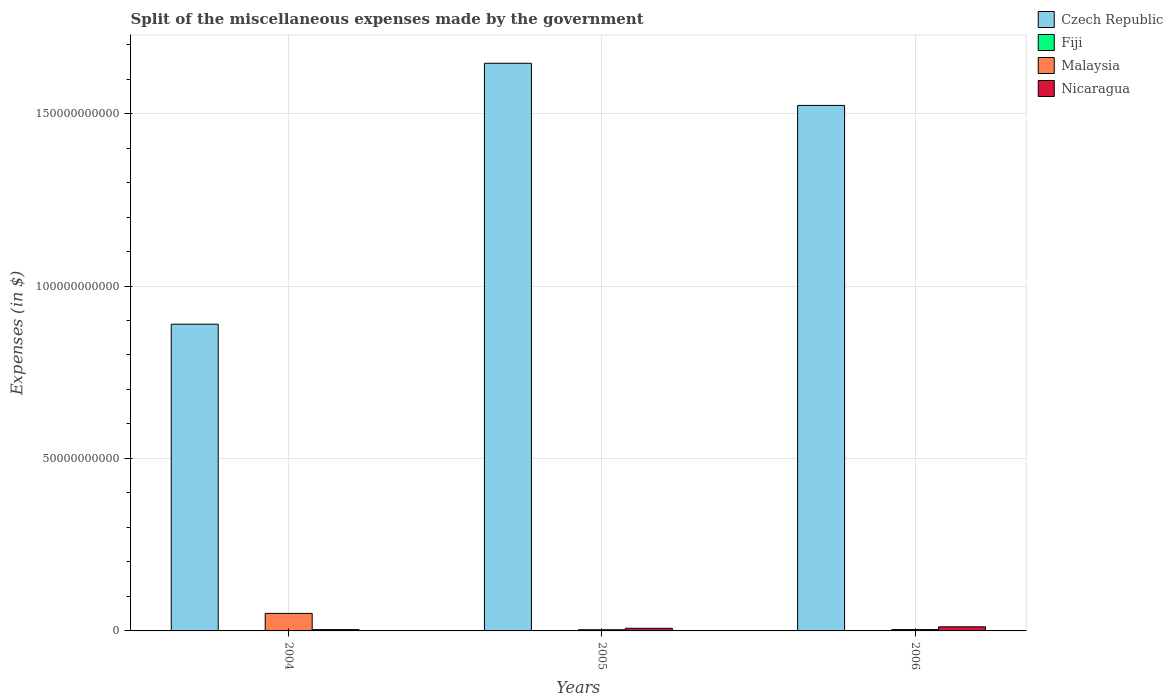How many different coloured bars are there?
Offer a terse response. 4. Are the number of bars on each tick of the X-axis equal?
Ensure brevity in your answer.  Yes. How many bars are there on the 2nd tick from the right?
Make the answer very short. 4. In how many cases, is the number of bars for a given year not equal to the number of legend labels?
Offer a terse response. 0. What is the miscellaneous expenses made by the government in Fiji in 2006?
Provide a short and direct response. 1.16e+08. Across all years, what is the maximum miscellaneous expenses made by the government in Fiji?
Provide a succinct answer. 1.16e+08. Across all years, what is the minimum miscellaneous expenses made by the government in Malaysia?
Give a very brief answer. 3.43e+08. In which year was the miscellaneous expenses made by the government in Czech Republic minimum?
Keep it short and to the point. 2004. What is the total miscellaneous expenses made by the government in Malaysia in the graph?
Make the answer very short. 5.82e+09. What is the difference between the miscellaneous expenses made by the government in Czech Republic in 2004 and that in 2005?
Your answer should be compact. -7.57e+1. What is the difference between the miscellaneous expenses made by the government in Czech Republic in 2006 and the miscellaneous expenses made by the government in Nicaragua in 2004?
Ensure brevity in your answer.  1.52e+11. What is the average miscellaneous expenses made by the government in Malaysia per year?
Offer a very short reply. 1.94e+09. In the year 2004, what is the difference between the miscellaneous expenses made by the government in Czech Republic and miscellaneous expenses made by the government in Fiji?
Provide a succinct answer. 8.88e+1. What is the ratio of the miscellaneous expenses made by the government in Fiji in 2005 to that in 2006?
Your answer should be compact. 0.89. Is the miscellaneous expenses made by the government in Nicaragua in 2004 less than that in 2006?
Your answer should be very brief. Yes. What is the difference between the highest and the second highest miscellaneous expenses made by the government in Nicaragua?
Keep it short and to the point. 4.25e+08. What is the difference between the highest and the lowest miscellaneous expenses made by the government in Fiji?
Your answer should be very brief. 2.09e+07. Is the sum of the miscellaneous expenses made by the government in Malaysia in 2004 and 2006 greater than the maximum miscellaneous expenses made by the government in Fiji across all years?
Offer a terse response. Yes. What does the 3rd bar from the left in 2005 represents?
Keep it short and to the point. Malaysia. What does the 1st bar from the right in 2004 represents?
Make the answer very short. Nicaragua. What is the difference between two consecutive major ticks on the Y-axis?
Give a very brief answer. 5.00e+1. How are the legend labels stacked?
Ensure brevity in your answer.  Vertical. What is the title of the graph?
Keep it short and to the point. Split of the miscellaneous expenses made by the government. Does "Fragile and conflict affected situations" appear as one of the legend labels in the graph?
Ensure brevity in your answer.  No. What is the label or title of the Y-axis?
Offer a terse response. Expenses (in $). What is the Expenses (in $) of Czech Republic in 2004?
Your response must be concise. 8.89e+1. What is the Expenses (in $) of Fiji in 2004?
Offer a terse response. 9.51e+07. What is the Expenses (in $) in Malaysia in 2004?
Your answer should be very brief. 5.08e+09. What is the Expenses (in $) in Nicaragua in 2004?
Your answer should be compact. 3.78e+08. What is the Expenses (in $) in Czech Republic in 2005?
Your answer should be compact. 1.65e+11. What is the Expenses (in $) in Fiji in 2005?
Make the answer very short. 1.04e+08. What is the Expenses (in $) in Malaysia in 2005?
Your answer should be compact. 3.43e+08. What is the Expenses (in $) of Nicaragua in 2005?
Provide a short and direct response. 7.65e+08. What is the Expenses (in $) of Czech Republic in 2006?
Provide a succinct answer. 1.52e+11. What is the Expenses (in $) in Fiji in 2006?
Your response must be concise. 1.16e+08. What is the Expenses (in $) in Malaysia in 2006?
Ensure brevity in your answer.  3.91e+08. What is the Expenses (in $) of Nicaragua in 2006?
Offer a very short reply. 1.19e+09. Across all years, what is the maximum Expenses (in $) of Czech Republic?
Offer a terse response. 1.65e+11. Across all years, what is the maximum Expenses (in $) in Fiji?
Offer a terse response. 1.16e+08. Across all years, what is the maximum Expenses (in $) of Malaysia?
Keep it short and to the point. 5.08e+09. Across all years, what is the maximum Expenses (in $) in Nicaragua?
Provide a succinct answer. 1.19e+09. Across all years, what is the minimum Expenses (in $) in Czech Republic?
Your answer should be very brief. 8.89e+1. Across all years, what is the minimum Expenses (in $) in Fiji?
Make the answer very short. 9.51e+07. Across all years, what is the minimum Expenses (in $) of Malaysia?
Provide a succinct answer. 3.43e+08. Across all years, what is the minimum Expenses (in $) of Nicaragua?
Give a very brief answer. 3.78e+08. What is the total Expenses (in $) in Czech Republic in the graph?
Offer a terse response. 4.06e+11. What is the total Expenses (in $) of Fiji in the graph?
Provide a short and direct response. 3.15e+08. What is the total Expenses (in $) of Malaysia in the graph?
Provide a short and direct response. 5.82e+09. What is the total Expenses (in $) of Nicaragua in the graph?
Offer a very short reply. 2.33e+09. What is the difference between the Expenses (in $) in Czech Republic in 2004 and that in 2005?
Ensure brevity in your answer.  -7.57e+1. What is the difference between the Expenses (in $) in Fiji in 2004 and that in 2005?
Offer a terse response. -8.37e+06. What is the difference between the Expenses (in $) of Malaysia in 2004 and that in 2005?
Provide a succinct answer. 4.74e+09. What is the difference between the Expenses (in $) of Nicaragua in 2004 and that in 2005?
Offer a very short reply. -3.87e+08. What is the difference between the Expenses (in $) in Czech Republic in 2004 and that in 2006?
Offer a terse response. -6.34e+1. What is the difference between the Expenses (in $) of Fiji in 2004 and that in 2006?
Make the answer very short. -2.09e+07. What is the difference between the Expenses (in $) in Malaysia in 2004 and that in 2006?
Your answer should be compact. 4.69e+09. What is the difference between the Expenses (in $) of Nicaragua in 2004 and that in 2006?
Keep it short and to the point. -8.12e+08. What is the difference between the Expenses (in $) of Czech Republic in 2005 and that in 2006?
Make the answer very short. 1.22e+1. What is the difference between the Expenses (in $) of Fiji in 2005 and that in 2006?
Ensure brevity in your answer.  -1.25e+07. What is the difference between the Expenses (in $) of Malaysia in 2005 and that in 2006?
Offer a very short reply. -4.78e+07. What is the difference between the Expenses (in $) of Nicaragua in 2005 and that in 2006?
Your answer should be compact. -4.25e+08. What is the difference between the Expenses (in $) in Czech Republic in 2004 and the Expenses (in $) in Fiji in 2005?
Give a very brief answer. 8.88e+1. What is the difference between the Expenses (in $) in Czech Republic in 2004 and the Expenses (in $) in Malaysia in 2005?
Give a very brief answer. 8.86e+1. What is the difference between the Expenses (in $) in Czech Republic in 2004 and the Expenses (in $) in Nicaragua in 2005?
Make the answer very short. 8.82e+1. What is the difference between the Expenses (in $) in Fiji in 2004 and the Expenses (in $) in Malaysia in 2005?
Your response must be concise. -2.48e+08. What is the difference between the Expenses (in $) in Fiji in 2004 and the Expenses (in $) in Nicaragua in 2005?
Make the answer very short. -6.70e+08. What is the difference between the Expenses (in $) of Malaysia in 2004 and the Expenses (in $) of Nicaragua in 2005?
Provide a succinct answer. 4.32e+09. What is the difference between the Expenses (in $) in Czech Republic in 2004 and the Expenses (in $) in Fiji in 2006?
Offer a terse response. 8.88e+1. What is the difference between the Expenses (in $) of Czech Republic in 2004 and the Expenses (in $) of Malaysia in 2006?
Provide a succinct answer. 8.85e+1. What is the difference between the Expenses (in $) of Czech Republic in 2004 and the Expenses (in $) of Nicaragua in 2006?
Your response must be concise. 8.77e+1. What is the difference between the Expenses (in $) in Fiji in 2004 and the Expenses (in $) in Malaysia in 2006?
Keep it short and to the point. -2.96e+08. What is the difference between the Expenses (in $) in Fiji in 2004 and the Expenses (in $) in Nicaragua in 2006?
Provide a short and direct response. -1.09e+09. What is the difference between the Expenses (in $) in Malaysia in 2004 and the Expenses (in $) in Nicaragua in 2006?
Provide a succinct answer. 3.89e+09. What is the difference between the Expenses (in $) in Czech Republic in 2005 and the Expenses (in $) in Fiji in 2006?
Offer a very short reply. 1.64e+11. What is the difference between the Expenses (in $) of Czech Republic in 2005 and the Expenses (in $) of Malaysia in 2006?
Provide a succinct answer. 1.64e+11. What is the difference between the Expenses (in $) in Czech Republic in 2005 and the Expenses (in $) in Nicaragua in 2006?
Your answer should be very brief. 1.63e+11. What is the difference between the Expenses (in $) of Fiji in 2005 and the Expenses (in $) of Malaysia in 2006?
Keep it short and to the point. -2.87e+08. What is the difference between the Expenses (in $) of Fiji in 2005 and the Expenses (in $) of Nicaragua in 2006?
Offer a terse response. -1.09e+09. What is the difference between the Expenses (in $) in Malaysia in 2005 and the Expenses (in $) in Nicaragua in 2006?
Your answer should be compact. -8.47e+08. What is the average Expenses (in $) of Czech Republic per year?
Provide a succinct answer. 1.35e+11. What is the average Expenses (in $) in Fiji per year?
Offer a very short reply. 1.05e+08. What is the average Expenses (in $) of Malaysia per year?
Your answer should be compact. 1.94e+09. What is the average Expenses (in $) of Nicaragua per year?
Your answer should be compact. 7.77e+08. In the year 2004, what is the difference between the Expenses (in $) of Czech Republic and Expenses (in $) of Fiji?
Your answer should be compact. 8.88e+1. In the year 2004, what is the difference between the Expenses (in $) in Czech Republic and Expenses (in $) in Malaysia?
Offer a terse response. 8.38e+1. In the year 2004, what is the difference between the Expenses (in $) of Czech Republic and Expenses (in $) of Nicaragua?
Your response must be concise. 8.86e+1. In the year 2004, what is the difference between the Expenses (in $) of Fiji and Expenses (in $) of Malaysia?
Provide a succinct answer. -4.99e+09. In the year 2004, what is the difference between the Expenses (in $) in Fiji and Expenses (in $) in Nicaragua?
Offer a very short reply. -2.83e+08. In the year 2004, what is the difference between the Expenses (in $) in Malaysia and Expenses (in $) in Nicaragua?
Your answer should be very brief. 4.70e+09. In the year 2005, what is the difference between the Expenses (in $) of Czech Republic and Expenses (in $) of Fiji?
Give a very brief answer. 1.64e+11. In the year 2005, what is the difference between the Expenses (in $) of Czech Republic and Expenses (in $) of Malaysia?
Provide a short and direct response. 1.64e+11. In the year 2005, what is the difference between the Expenses (in $) of Czech Republic and Expenses (in $) of Nicaragua?
Provide a succinct answer. 1.64e+11. In the year 2005, what is the difference between the Expenses (in $) of Fiji and Expenses (in $) of Malaysia?
Provide a short and direct response. -2.40e+08. In the year 2005, what is the difference between the Expenses (in $) in Fiji and Expenses (in $) in Nicaragua?
Your response must be concise. -6.62e+08. In the year 2005, what is the difference between the Expenses (in $) in Malaysia and Expenses (in $) in Nicaragua?
Your answer should be very brief. -4.22e+08. In the year 2006, what is the difference between the Expenses (in $) in Czech Republic and Expenses (in $) in Fiji?
Provide a short and direct response. 1.52e+11. In the year 2006, what is the difference between the Expenses (in $) of Czech Republic and Expenses (in $) of Malaysia?
Offer a terse response. 1.52e+11. In the year 2006, what is the difference between the Expenses (in $) in Czech Republic and Expenses (in $) in Nicaragua?
Your answer should be very brief. 1.51e+11. In the year 2006, what is the difference between the Expenses (in $) of Fiji and Expenses (in $) of Malaysia?
Offer a terse response. -2.75e+08. In the year 2006, what is the difference between the Expenses (in $) of Fiji and Expenses (in $) of Nicaragua?
Offer a very short reply. -1.07e+09. In the year 2006, what is the difference between the Expenses (in $) of Malaysia and Expenses (in $) of Nicaragua?
Ensure brevity in your answer.  -7.99e+08. What is the ratio of the Expenses (in $) of Czech Republic in 2004 to that in 2005?
Your response must be concise. 0.54. What is the ratio of the Expenses (in $) in Fiji in 2004 to that in 2005?
Give a very brief answer. 0.92. What is the ratio of the Expenses (in $) in Malaysia in 2004 to that in 2005?
Provide a short and direct response. 14.82. What is the ratio of the Expenses (in $) in Nicaragua in 2004 to that in 2005?
Give a very brief answer. 0.49. What is the ratio of the Expenses (in $) of Czech Republic in 2004 to that in 2006?
Your answer should be compact. 0.58. What is the ratio of the Expenses (in $) in Fiji in 2004 to that in 2006?
Your response must be concise. 0.82. What is the ratio of the Expenses (in $) in Malaysia in 2004 to that in 2006?
Your response must be concise. 13. What is the ratio of the Expenses (in $) in Nicaragua in 2004 to that in 2006?
Your answer should be very brief. 0.32. What is the ratio of the Expenses (in $) in Czech Republic in 2005 to that in 2006?
Ensure brevity in your answer.  1.08. What is the ratio of the Expenses (in $) of Fiji in 2005 to that in 2006?
Keep it short and to the point. 0.89. What is the ratio of the Expenses (in $) in Malaysia in 2005 to that in 2006?
Make the answer very short. 0.88. What is the ratio of the Expenses (in $) of Nicaragua in 2005 to that in 2006?
Give a very brief answer. 0.64. What is the difference between the highest and the second highest Expenses (in $) in Czech Republic?
Ensure brevity in your answer.  1.22e+1. What is the difference between the highest and the second highest Expenses (in $) in Fiji?
Ensure brevity in your answer.  1.25e+07. What is the difference between the highest and the second highest Expenses (in $) of Malaysia?
Ensure brevity in your answer.  4.69e+09. What is the difference between the highest and the second highest Expenses (in $) in Nicaragua?
Your answer should be very brief. 4.25e+08. What is the difference between the highest and the lowest Expenses (in $) in Czech Republic?
Keep it short and to the point. 7.57e+1. What is the difference between the highest and the lowest Expenses (in $) in Fiji?
Ensure brevity in your answer.  2.09e+07. What is the difference between the highest and the lowest Expenses (in $) of Malaysia?
Your response must be concise. 4.74e+09. What is the difference between the highest and the lowest Expenses (in $) in Nicaragua?
Offer a terse response. 8.12e+08. 